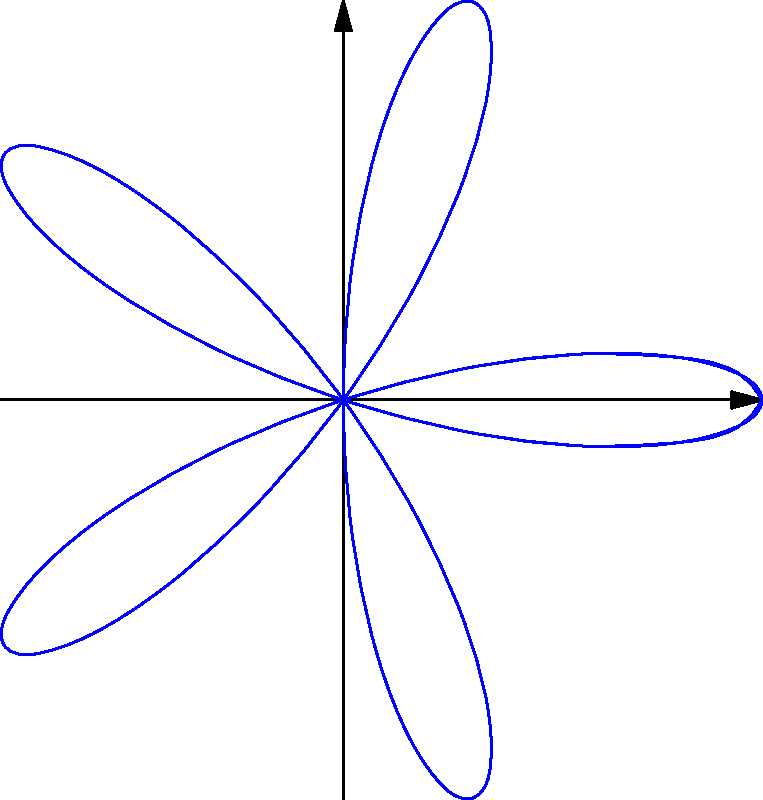In the context of art authentication, consider the rose curve given by the polar equation $r = \cos(5\theta)$. What is the degree of rotational symmetry for this curve, and how might this property be useful in identifying potential forgeries of artworks featuring this pattern? To determine the rotational symmetry of this rose curve, we need to follow these steps:

1) The general equation for a rose curve is $r = \cos(n\theta)$ or $r = \sin(n\theta)$, where $n$ is an integer.

2) In this case, we have $r = \cos(5\theta)$.

3) For rose curves:
   - If $n$ is odd, the curve has $n$ petals.
   - If $n$ is even, the curve has $2n$ petals.

4) Here, $n = 5$, which is odd. Therefore, this curve has 5 petals.

5) The degree of rotational symmetry is equal to the number of petals for odd $n$.

6) Thus, this curve has 5-fold rotational symmetry, meaning it looks the same after rotating by $\frac{360^\circ}{5} = 72^\circ$.

In art authentication, this property could be useful because:

a) Genuine artworks featuring this pattern would maintain perfect 5-fold symmetry.
b) Forgeries might have slight imperfections in symmetry due to human error in reproduction.
c) Authentication experts could use digital tools to measure the exact angles and proportions of the curve to verify its mathematical precision.
d) Any deviation from the expected symmetry could indicate a potential forgery or restoration work.
Answer: 5-fold rotational symmetry 